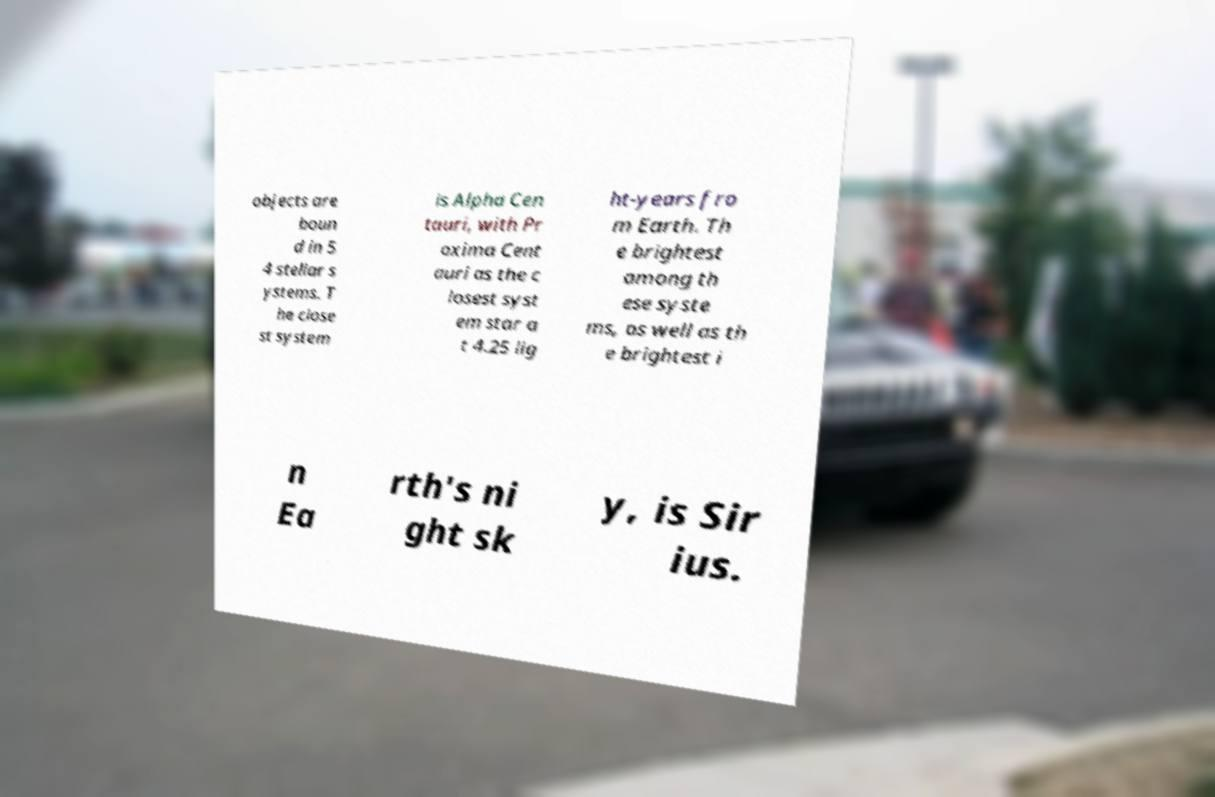Please identify and transcribe the text found in this image. objects are boun d in 5 4 stellar s ystems. T he close st system is Alpha Cen tauri, with Pr oxima Cent auri as the c losest syst em star a t 4.25 lig ht-years fro m Earth. Th e brightest among th ese syste ms, as well as th e brightest i n Ea rth's ni ght sk y, is Sir ius. 